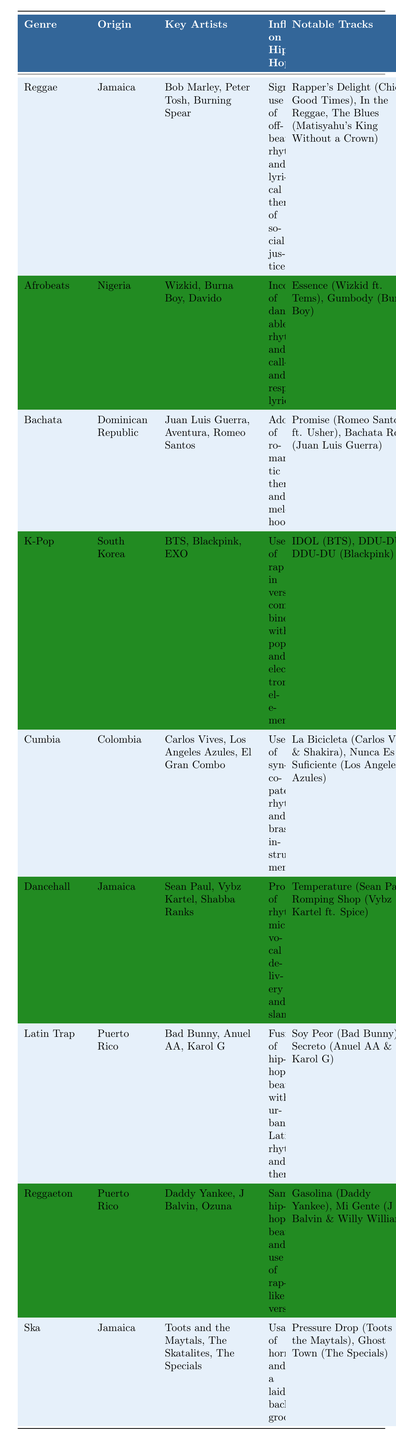What is the origin country of Reggae music? Reggae music originated in Jamaica, as stated in the "Origin" column of the table.
Answer: Jamaica Name two key artists associated with Afrobeats. The table lists Wizkid, Burna Boy, and Davido as key artists of Afrobeats. Among these, I can name two: Wizkid and Burna Boy.
Answer: Wizkid, Burna Boy Does Latin Trap incorporate hip-hop beats in its music? The table indicates that Latin Trap is a fusion of hip-hop beats with urban Latin rhythms, confirming that hip-hop beats are indeed incorporated.
Answer: Yes Which genre focuses on romantic themes and melodic hooks? According to the "Influence on Hip-Hop" section, the genre that focuses on romantic themes and melodic hooks is Bachata, as described in that column.
Answer: Bachata How many genres listed originated in Jamaica? The table shows that there are three genres originating from Jamaica: Reggae, Dancehall, and Ska. Therefore, the total number is three.
Answer: 3 What notable track is associated with K-Pop? The notable tracks listed for K-Pop include IDOL (BTS) and DDU-DU DDU-DU (Blackpink); therefore, IDOL is one of the notable tracks.
Answer: IDOL (BTS) Which genre combines danceable rhythms with call-and-response lyrics? The influence on Hip-Hop section specifies that Afrobeats incorporates danceable rhythms and call-and-response lyrics, indicating that this genre fits the description.
Answer: Afrobeats If we consider the genres originating in Puerto Rico, which ones involve rap-like verses? The table shows that both Latin Trap and Reggaeton involve rap-like verses. The influences listed confirm this aspect for both genres.
Answer: Latin Trap, Reggaeton What is the influence of Cumbia on Hip-Hop? The table describes Cumbia's influence as the use of syncopated rhythms and brass instruments, showing its impact on the genre.
Answer: Syncopated rhythms and brass instruments Are there any genres listed that originated from South Korea? Yes, the table lists K-Pop as the genre that originated in South Korea, confirming the presence of this genre in the specified country.
Answer: Yes 